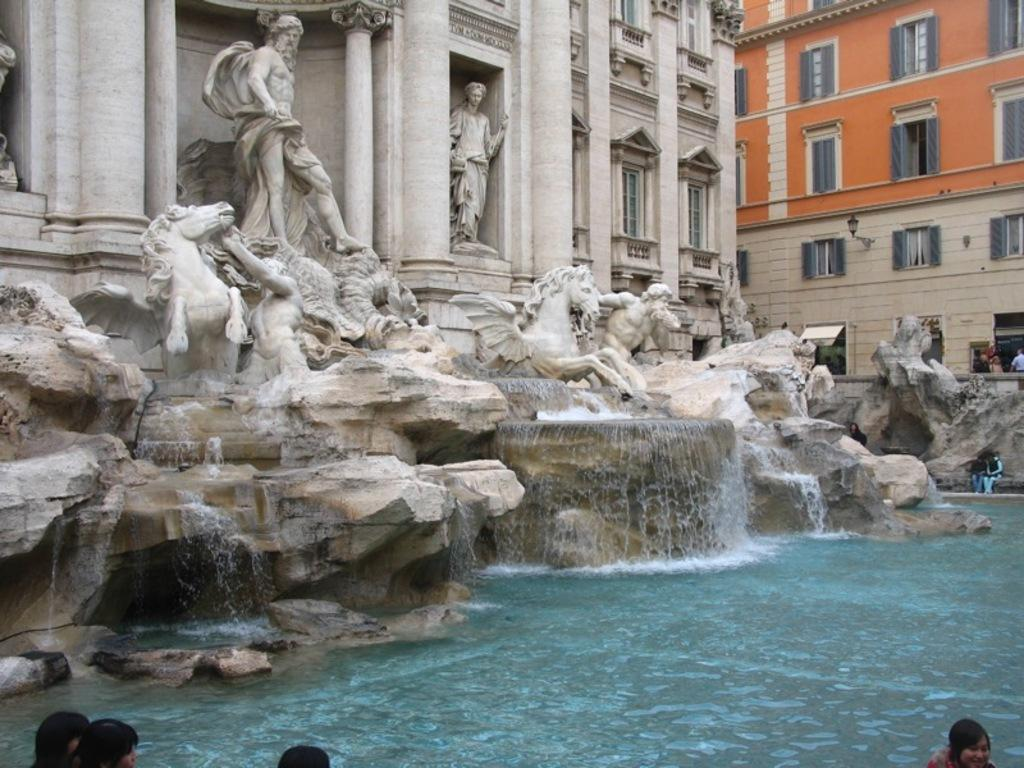What type of structure is present in the image? There is a building with statues in the image. What can be seen at the bottom of the image? There is water visible at the bottom of the image. Are there any people in the image? Yes, there are people in the image. What is the appearance of the building on the right side of the image? There is a building with windows on the right side of the image. What type of reaction can be seen from the bead in the image? There is no bead present in the image, so it is not possible to determine any reaction. Is there a bike visible in the image? No, there is no bike present in the image. 